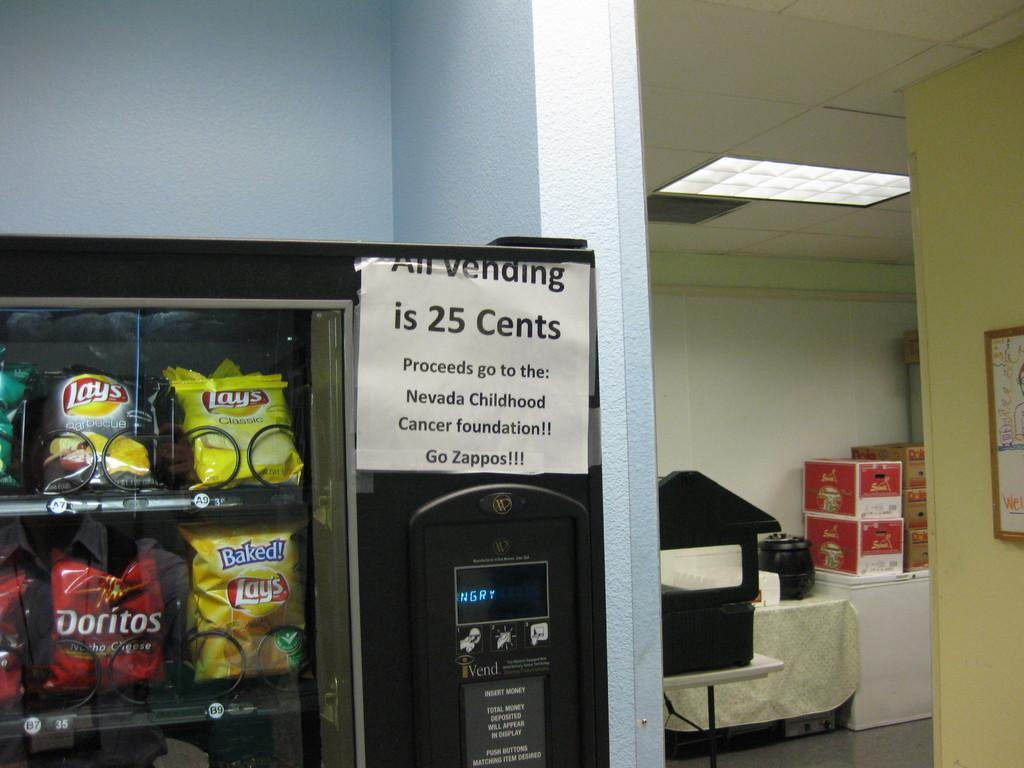<image>
Present a compact description of the photo's key features. Vending machine selling potato chips including bags of Doritos. 